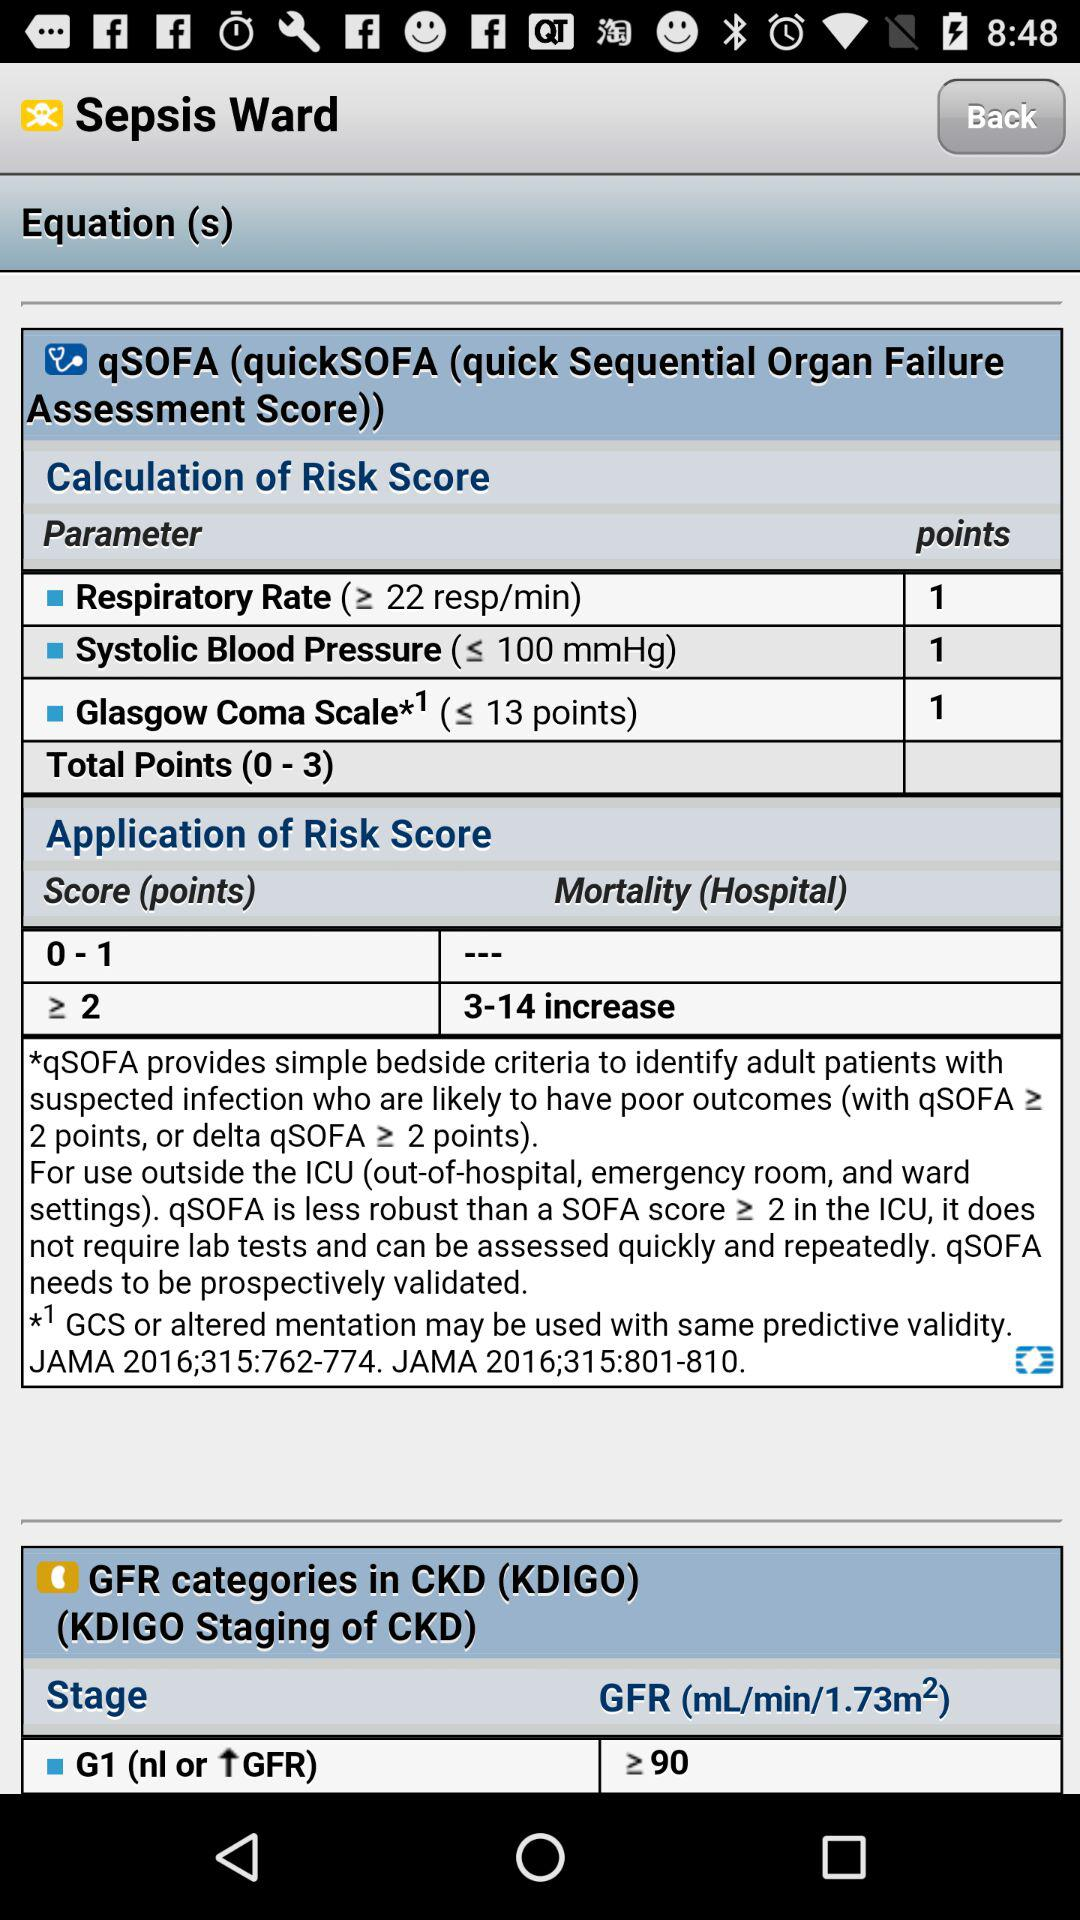How much does the mortality score of 3–14 increase? The mortality score is greater than or equal to 2. 